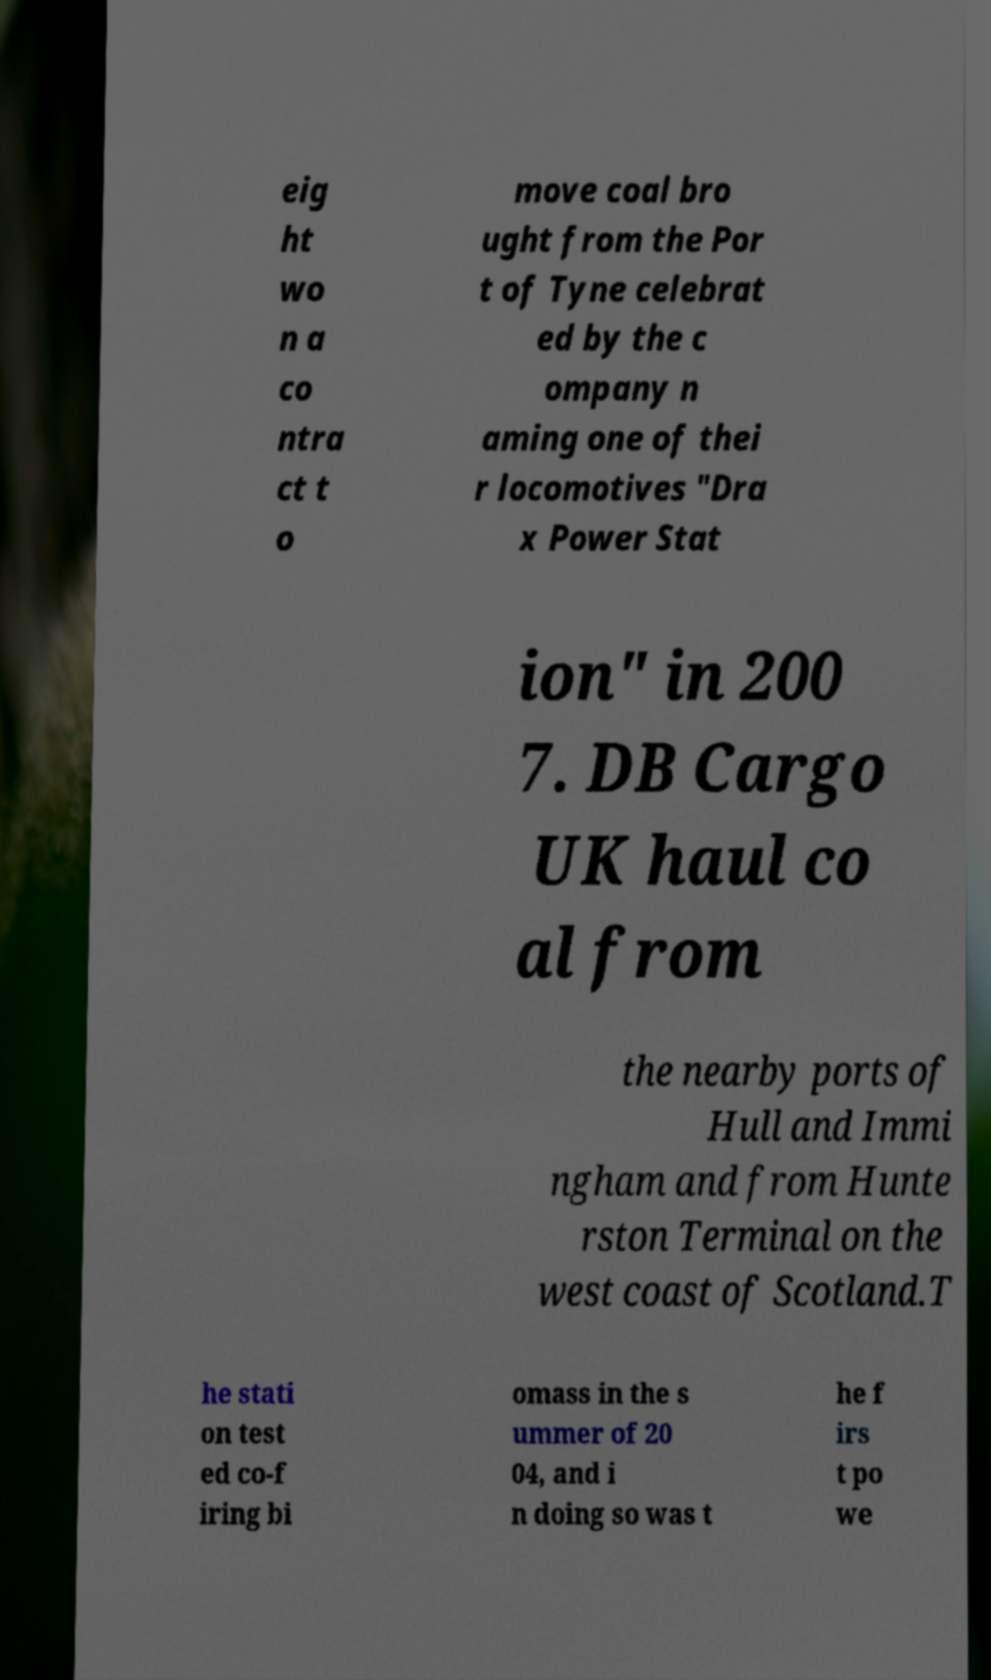Can you accurately transcribe the text from the provided image for me? eig ht wo n a co ntra ct t o move coal bro ught from the Por t of Tyne celebrat ed by the c ompany n aming one of thei r locomotives "Dra x Power Stat ion" in 200 7. DB Cargo UK haul co al from the nearby ports of Hull and Immi ngham and from Hunte rston Terminal on the west coast of Scotland.T he stati on test ed co-f iring bi omass in the s ummer of 20 04, and i n doing so was t he f irs t po we 